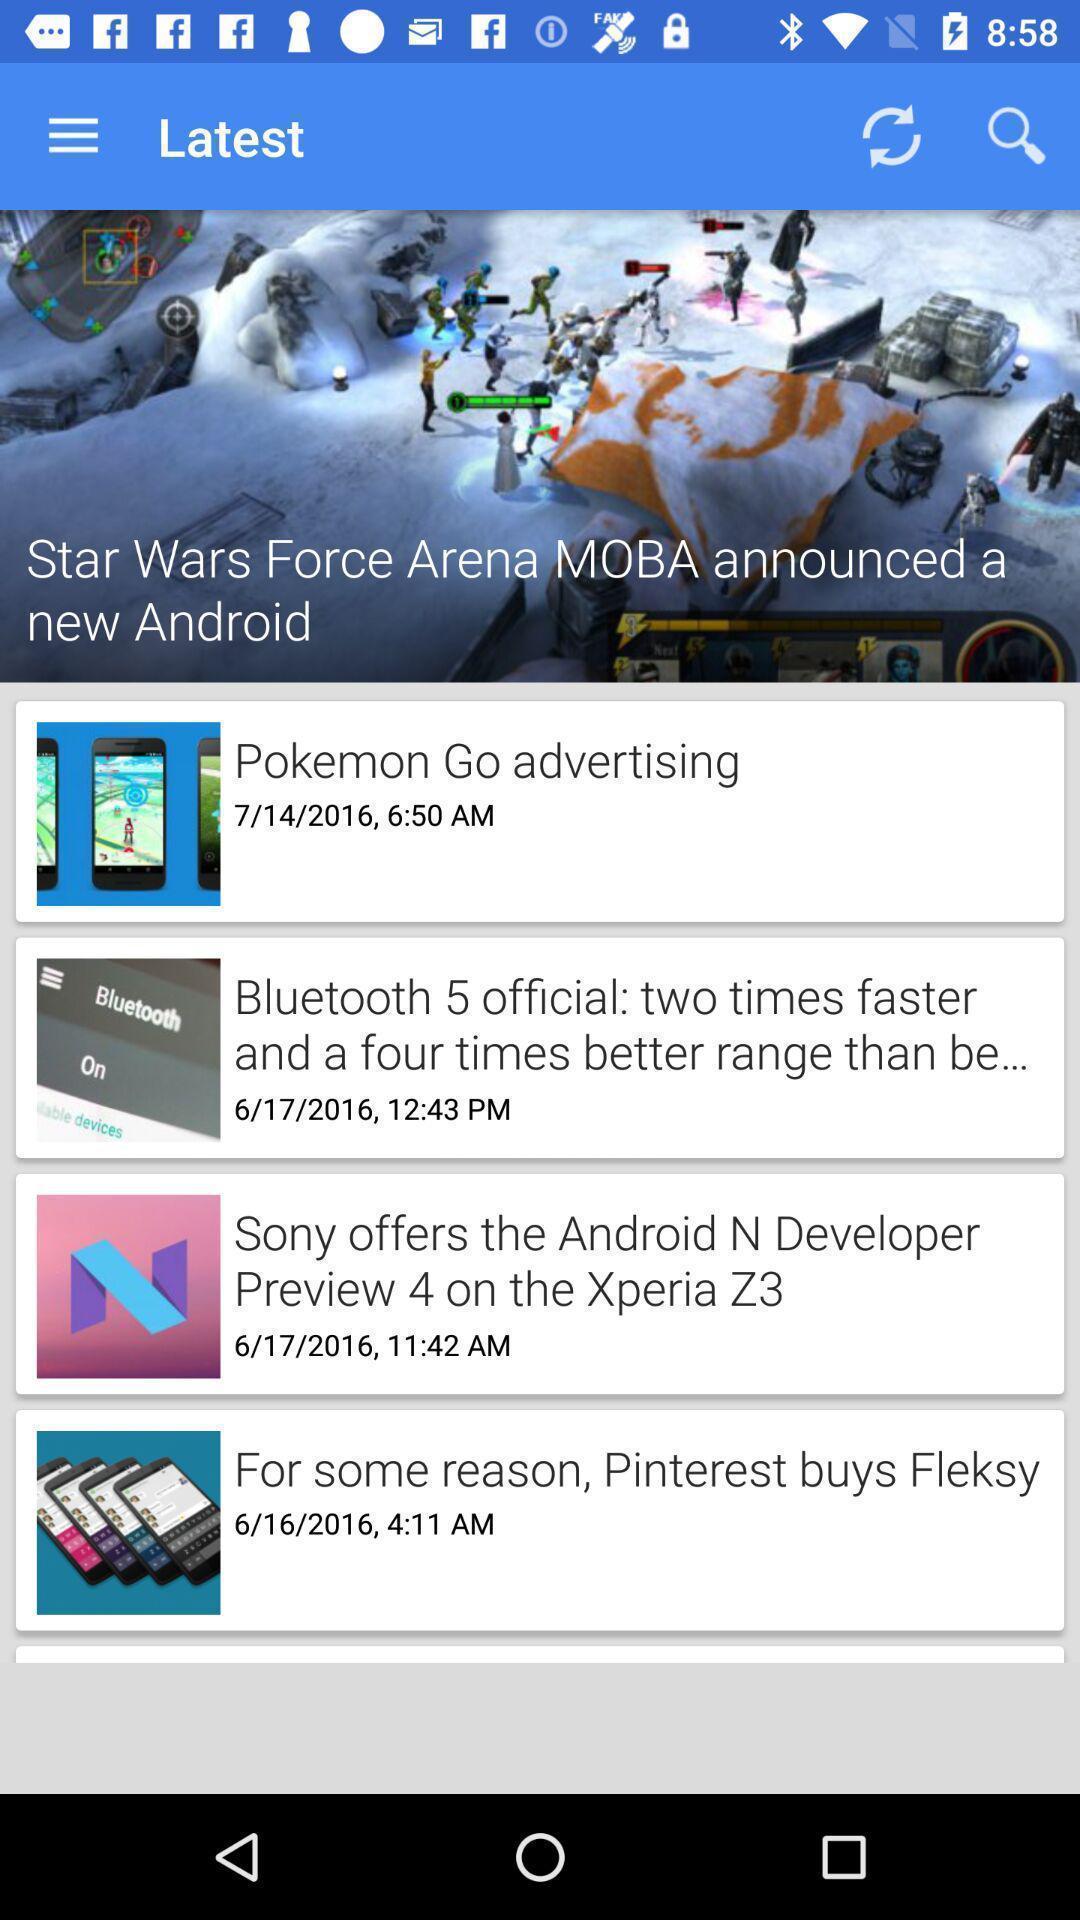Describe the visual elements of this screenshot. Screen displaying list of news. 